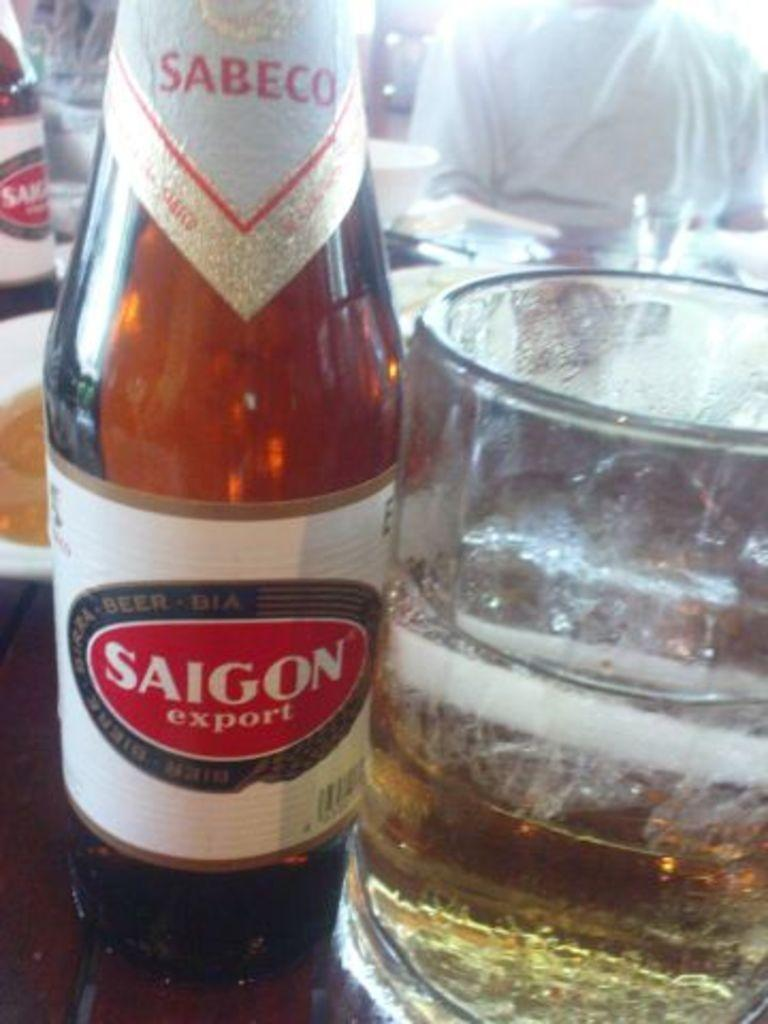<image>
Provide a brief description of the given image. A brown bottle has a label with Saigon and export on it. 